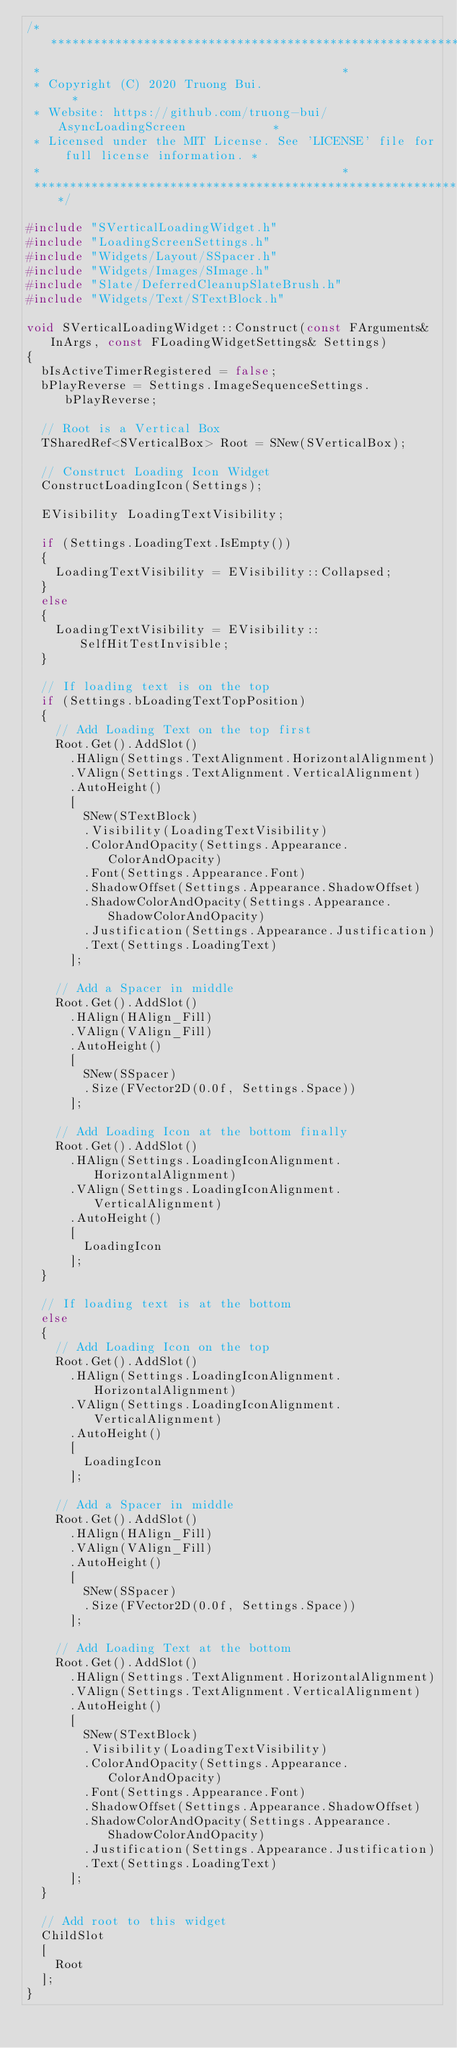Convert code to text. <code><loc_0><loc_0><loc_500><loc_500><_C++_>/************************************************************************************
 *																					*
 * Copyright (C) 2020 Truong Bui.													*
 * Website:	https://github.com/truong-bui/AsyncLoadingScreen						*
 * Licensed under the MIT License. See 'LICENSE' file for full license information. *
 *																					*
 ************************************************************************************/

#include "SVerticalLoadingWidget.h"
#include "LoadingScreenSettings.h"
#include "Widgets/Layout/SSpacer.h"
#include "Widgets/Images/SImage.h"
#include "Slate/DeferredCleanupSlateBrush.h"
#include "Widgets/Text/STextBlock.h"

void SVerticalLoadingWidget::Construct(const FArguments& InArgs, const FLoadingWidgetSettings& Settings)
{
	bIsActiveTimerRegistered = false;
	bPlayReverse = Settings.ImageSequenceSettings.bPlayReverse;

	// Root is a Vertical Box
	TSharedRef<SVerticalBox> Root = SNew(SVerticalBox);

	// Construct Loading Icon Widget
	ConstructLoadingIcon(Settings);

	EVisibility LoadingTextVisibility;

	if (Settings.LoadingText.IsEmpty())
	{
		LoadingTextVisibility = EVisibility::Collapsed;
	}
	else
	{
		LoadingTextVisibility = EVisibility::SelfHitTestInvisible;
	}

	// If loading text is on the top
	if (Settings.bLoadingTextTopPosition)
	{
		// Add Loading Text on the top first
		Root.Get().AddSlot()
			.HAlign(Settings.TextAlignment.HorizontalAlignment)
			.VAlign(Settings.TextAlignment.VerticalAlignment)
			.AutoHeight()
			[
				SNew(STextBlock)
				.Visibility(LoadingTextVisibility)
				.ColorAndOpacity(Settings.Appearance.ColorAndOpacity)
				.Font(Settings.Appearance.Font)
				.ShadowOffset(Settings.Appearance.ShadowOffset)
				.ShadowColorAndOpacity(Settings.Appearance.ShadowColorAndOpacity)
				.Justification(Settings.Appearance.Justification)
				.Text(Settings.LoadingText)				
			];

		// Add a Spacer in middle
		Root.Get().AddSlot()
			.HAlign(HAlign_Fill)
			.VAlign(VAlign_Fill)
			.AutoHeight()
			[
				SNew(SSpacer)
				.Size(FVector2D(0.0f, Settings.Space))
			];

		// Add Loading Icon at the bottom finally
		Root.Get().AddSlot()
			.HAlign(Settings.LoadingIconAlignment.HorizontalAlignment)
			.VAlign(Settings.LoadingIconAlignment.VerticalAlignment)
			.AutoHeight()
			[
				LoadingIcon
			];
	}

	// If loading text is at the bottom
	else
	{
		// Add Loading Icon on the top
		Root.Get().AddSlot()
			.HAlign(Settings.LoadingIconAlignment.HorizontalAlignment)
			.VAlign(Settings.LoadingIconAlignment.VerticalAlignment)
			.AutoHeight()
			[
				LoadingIcon
			];

		// Add a Spacer in middle
		Root.Get().AddSlot()
			.HAlign(HAlign_Fill)
			.VAlign(VAlign_Fill)
			.AutoHeight()
			[
				SNew(SSpacer)
				.Size(FVector2D(0.0f, Settings.Space))
			];

		// Add Loading Text at the bottom
		Root.Get().AddSlot()
			.HAlign(Settings.TextAlignment.HorizontalAlignment)
			.VAlign(Settings.TextAlignment.VerticalAlignment)
			.AutoHeight()
			[
				SNew(STextBlock)
				.Visibility(LoadingTextVisibility)
				.ColorAndOpacity(Settings.Appearance.ColorAndOpacity)
				.Font(Settings.Appearance.Font)
				.ShadowOffset(Settings.Appearance.ShadowOffset)
				.ShadowColorAndOpacity(Settings.Appearance.ShadowColorAndOpacity)
				.Justification(Settings.Appearance.Justification)
				.Text(Settings.LoadingText)				
			];
	}

	// Add root to this widget
	ChildSlot
	[
		Root
	];
}
</code> 